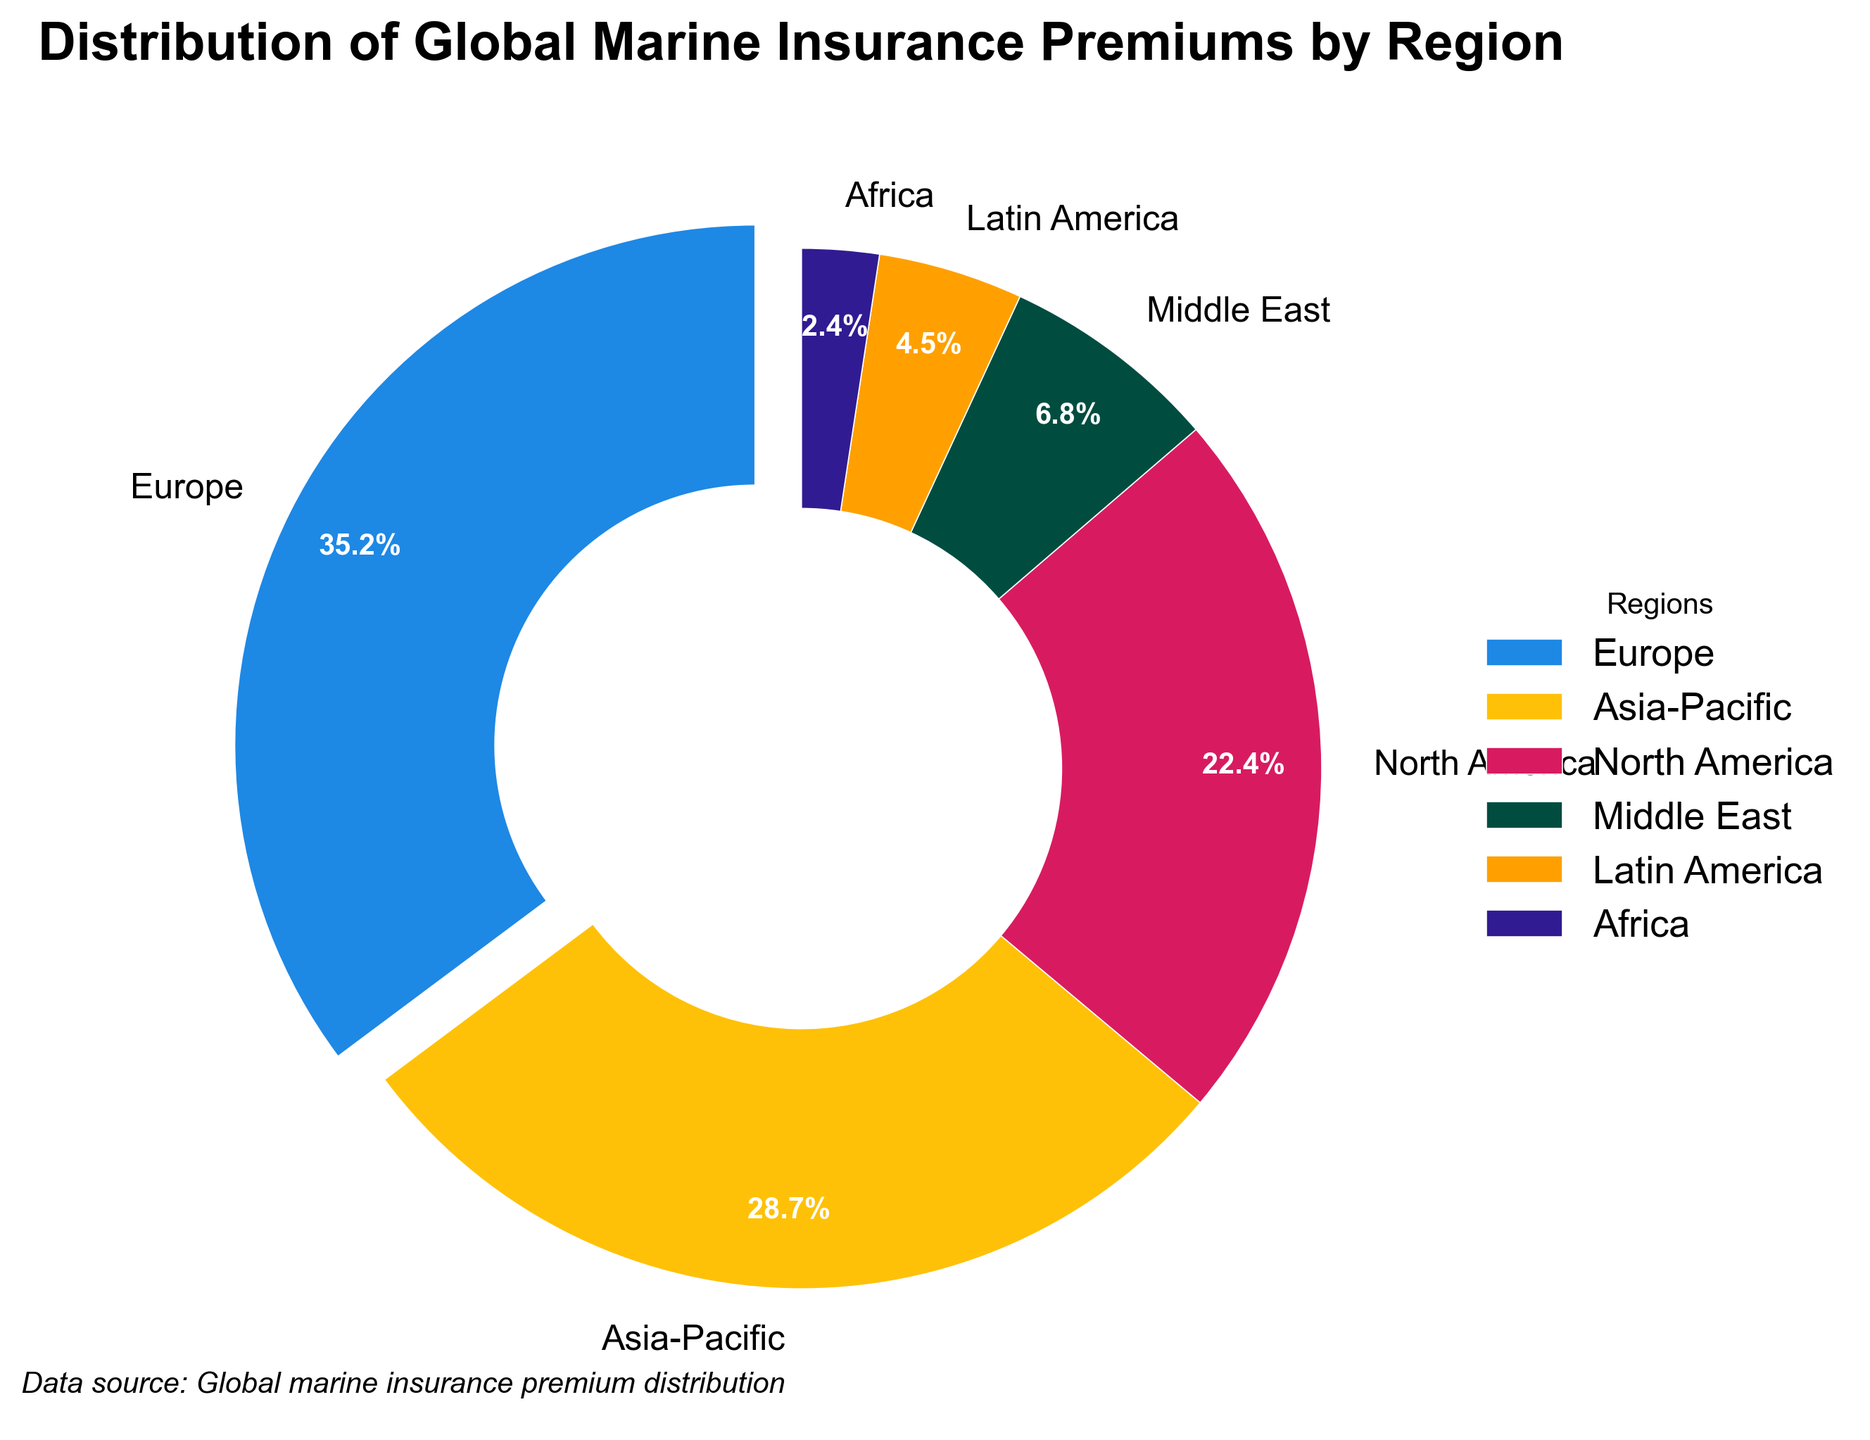What's the largest percentage value shown in the pie chart, and which region does it correspond to? The pie chart shows the percentage values of different regions, and the region with the largest percentage should be selected. The largest percentage is 35.2%, corresponding to Europe.
Answer: 35.2%, Europe What is the combined percentage of the Middle East and Latin America? To find the combined percentage, add the individual percentages of the Middle East (6.8%) and Latin America (4.5%). 6.8 + 4.5 = 11.3
Answer: 11.3% Is Asia-Pacific’s percentage greater than North America’s percentage? Look at the pie chart and compare the percentages for Asia-Pacific (28.7%) and North America (22.4%). Since 28.7 is greater than 22.4, the answer is yes.
Answer: Yes Which region has the smallest percentage share, and what is that percentage? The pie chart shows the percentage values of different regions, and the smallest percentage is identified. Africa has the smallest share at 2.4%.
Answer: Africa, 2.4% What are the colors used for the Asia-Pacific and North America regions? Identify the colors in the pie chart corresponding to Asia-Pacific and North America. Asia-Pacific is yellow, and North America is red.
Answer: yellow, red What is the sum of the percentages for Europe, Asia-Pacific, and North America? Calculate the sum by adding the percentages for Europe (35.2%), Asia-Pacific (28.7%), and North America (22.4%). 35.2 + 28.7 + 22.4 = 86.3
Answer: 86.3% By what percentage does Europe lead compared to the Middle East? Subtract the Middle East's percentage (6.8%) from Europe’s percentage (35.2%). 35.2 - 6.8 = 28.4
Answer: 28.4% How many regions have a percentage share of less than 10%? Look at the pie chart and count the regions with percentage shares below 10%. The regions are the Middle East, Latin America, and Africa (6.8%, 4.5%, 2.4%), totaling 3 regions.
Answer: 3 What is the title of the pie chart, and how does it describe the data? Read the title of the pie chart. The title is "Distribution of Global Marine Insurance Premiums by Region," which describes the data as the percentage share of marine insurance premiums among different regions globally.
Answer: Distribution of Global Marine Insurance Premiums by Region What is the percentage difference between the Asia-Pacific and Europe regions? Subtract the Asia-Pacific percentage (28.7%) from Europe’s percentage (35.2%). 35.2 - 28.7 = 6.5
Answer: 6.5%eakfi 